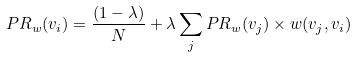<formula> <loc_0><loc_0><loc_500><loc_500>P R _ { w } ( v _ { i } ) = \frac { \left ( 1 - \lambda \right ) } { N } + \lambda \sum _ { j } P R _ { w } ( v _ { j } ) \times w ( v _ { j } , v _ { i } )</formula> 